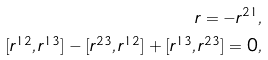Convert formula to latex. <formula><loc_0><loc_0><loc_500><loc_500>r = - r ^ { 2 1 } , \\ [ r ^ { 1 2 } , r ^ { 1 3 } ] - [ r ^ { 2 3 } , r ^ { 1 2 } ] + [ r ^ { 1 3 } , r ^ { 2 3 } ] = 0 ,</formula> 